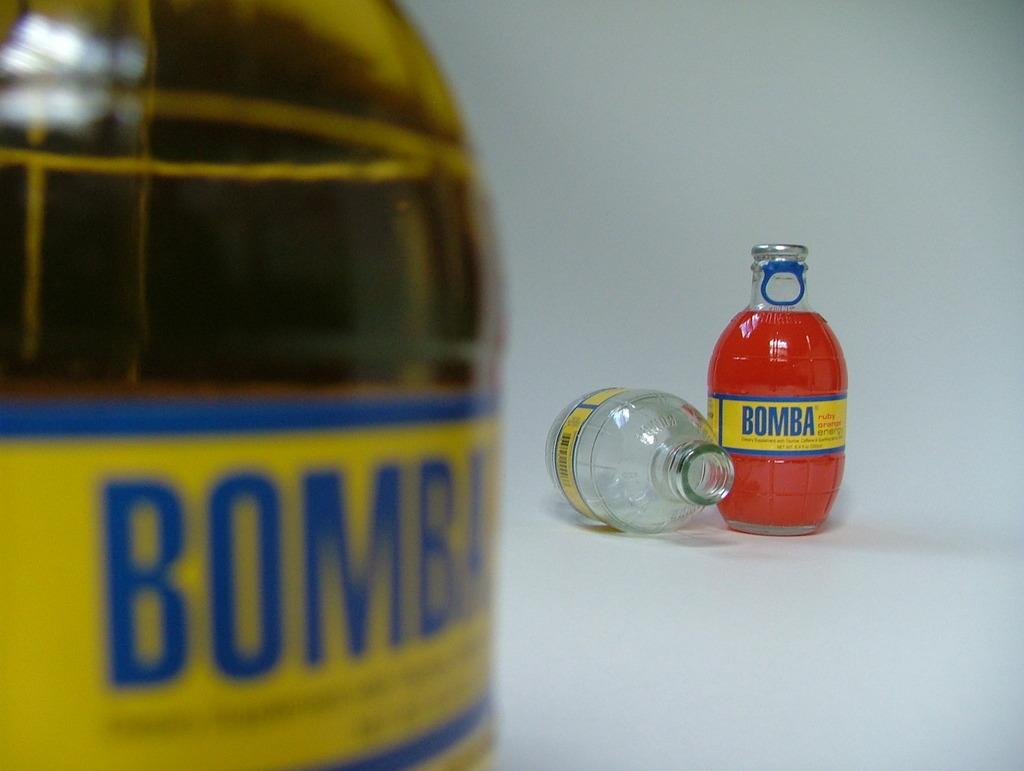What is the name of this beverage?
Keep it short and to the point. Bomba. 